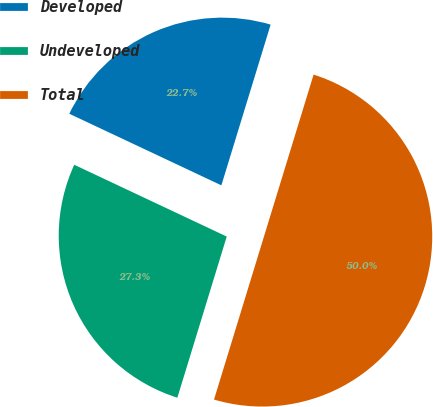Convert chart. <chart><loc_0><loc_0><loc_500><loc_500><pie_chart><fcel>Developed<fcel>Undeveloped<fcel>Total<nl><fcel>22.73%<fcel>27.27%<fcel>50.0%<nl></chart> 